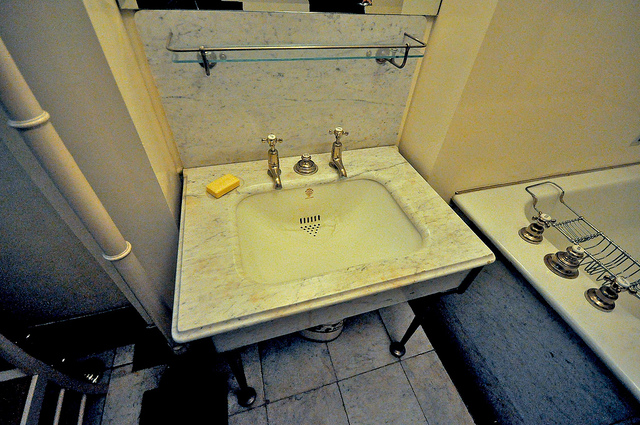Are there any objects hanging or stored above the sink? No, there are no objects hanging or stored directly above the sink. The area appears clear except for a glass shelf mounted on the wall. 